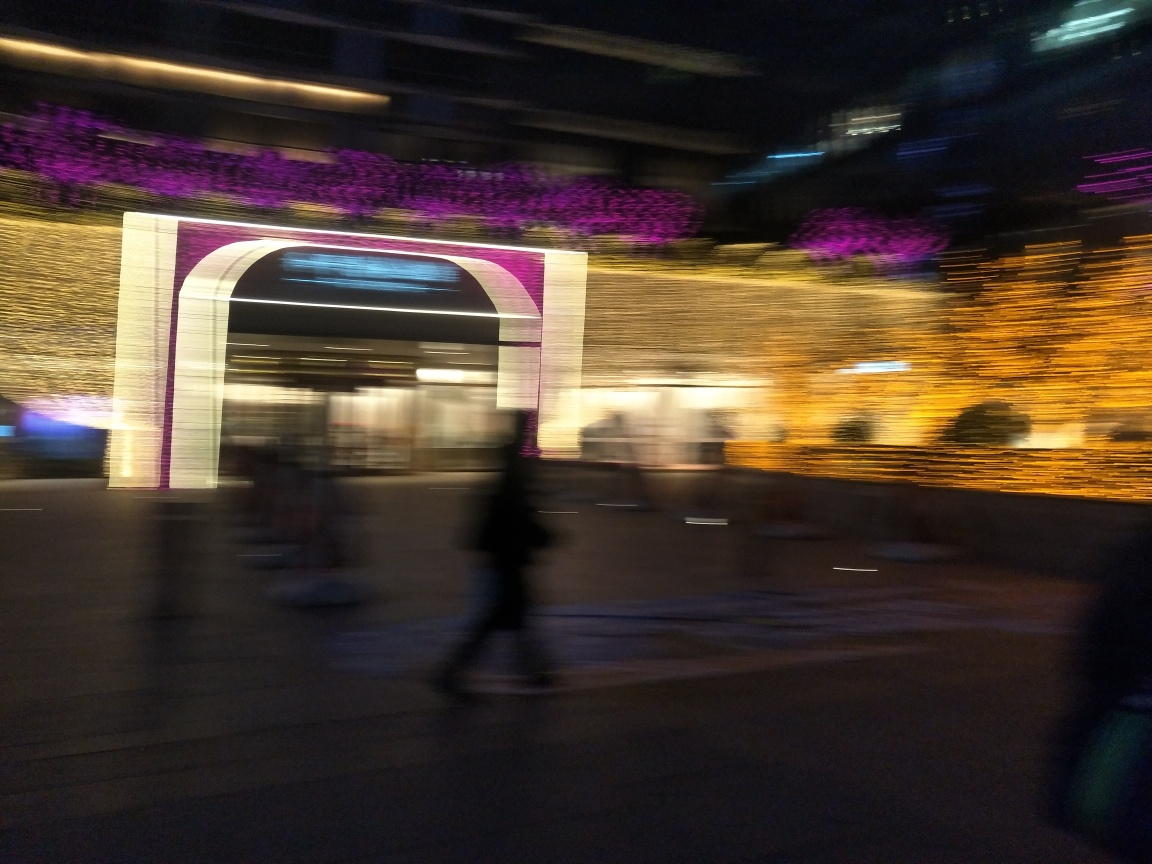Can you guess the type of location or venue depicted in this photo? It seems to be an urban outdoor setting, possibly a street or public square with modern decorative lighting, which could indicate a festive or special event taking place. 